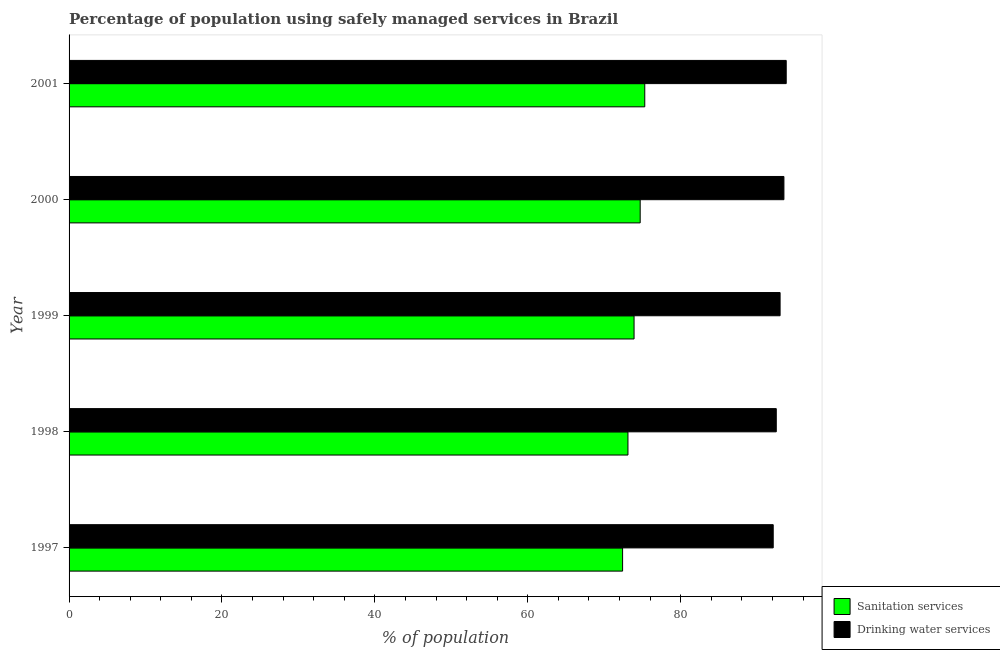How many different coloured bars are there?
Offer a very short reply. 2. How many bars are there on the 5th tick from the top?
Your answer should be compact. 2. In how many cases, is the number of bars for a given year not equal to the number of legend labels?
Give a very brief answer. 0. What is the percentage of population who used drinking water services in 2001?
Keep it short and to the point. 93.8. Across all years, what is the maximum percentage of population who used drinking water services?
Ensure brevity in your answer.  93.8. Across all years, what is the minimum percentage of population who used sanitation services?
Provide a short and direct response. 72.4. In which year was the percentage of population who used sanitation services maximum?
Give a very brief answer. 2001. In which year was the percentage of population who used sanitation services minimum?
Offer a terse response. 1997. What is the total percentage of population who used sanitation services in the graph?
Provide a short and direct response. 369.4. What is the difference between the percentage of population who used sanitation services in 1998 and the percentage of population who used drinking water services in 1997?
Offer a terse response. -19. What is the average percentage of population who used drinking water services per year?
Ensure brevity in your answer.  92.98. In the year 1999, what is the difference between the percentage of population who used sanitation services and percentage of population who used drinking water services?
Your answer should be very brief. -19.1. In how many years, is the percentage of population who used sanitation services greater than 92 %?
Ensure brevity in your answer.  0. Is the percentage of population who used sanitation services in 1997 less than that in 2000?
Keep it short and to the point. Yes. Is the sum of the percentage of population who used drinking water services in 1999 and 2001 greater than the maximum percentage of population who used sanitation services across all years?
Ensure brevity in your answer.  Yes. What does the 2nd bar from the top in 1997 represents?
Your response must be concise. Sanitation services. What does the 2nd bar from the bottom in 1999 represents?
Your answer should be very brief. Drinking water services. How many years are there in the graph?
Offer a very short reply. 5. Does the graph contain any zero values?
Offer a terse response. No. Where does the legend appear in the graph?
Your answer should be compact. Bottom right. How many legend labels are there?
Your answer should be compact. 2. What is the title of the graph?
Ensure brevity in your answer.  Percentage of population using safely managed services in Brazil. Does "Taxes on exports" appear as one of the legend labels in the graph?
Offer a terse response. No. What is the label or title of the X-axis?
Keep it short and to the point. % of population. What is the label or title of the Y-axis?
Offer a terse response. Year. What is the % of population of Sanitation services in 1997?
Your answer should be very brief. 72.4. What is the % of population of Drinking water services in 1997?
Make the answer very short. 92.1. What is the % of population in Sanitation services in 1998?
Your response must be concise. 73.1. What is the % of population of Drinking water services in 1998?
Offer a terse response. 92.5. What is the % of population in Sanitation services in 1999?
Ensure brevity in your answer.  73.9. What is the % of population of Drinking water services in 1999?
Provide a short and direct response. 93. What is the % of population in Sanitation services in 2000?
Offer a terse response. 74.7. What is the % of population of Drinking water services in 2000?
Keep it short and to the point. 93.5. What is the % of population of Sanitation services in 2001?
Your answer should be compact. 75.3. What is the % of population of Drinking water services in 2001?
Your response must be concise. 93.8. Across all years, what is the maximum % of population in Sanitation services?
Your answer should be compact. 75.3. Across all years, what is the maximum % of population in Drinking water services?
Provide a short and direct response. 93.8. Across all years, what is the minimum % of population of Sanitation services?
Make the answer very short. 72.4. Across all years, what is the minimum % of population in Drinking water services?
Offer a very short reply. 92.1. What is the total % of population in Sanitation services in the graph?
Your answer should be compact. 369.4. What is the total % of population of Drinking water services in the graph?
Give a very brief answer. 464.9. What is the difference between the % of population of Sanitation services in 1997 and that in 1998?
Provide a succinct answer. -0.7. What is the difference between the % of population in Drinking water services in 1997 and that in 1998?
Offer a terse response. -0.4. What is the difference between the % of population of Drinking water services in 1997 and that in 1999?
Provide a short and direct response. -0.9. What is the difference between the % of population of Sanitation services in 1997 and that in 2000?
Keep it short and to the point. -2.3. What is the difference between the % of population of Sanitation services in 1997 and that in 2001?
Provide a short and direct response. -2.9. What is the difference between the % of population of Drinking water services in 1997 and that in 2001?
Ensure brevity in your answer.  -1.7. What is the difference between the % of population in Sanitation services in 1998 and that in 1999?
Give a very brief answer. -0.8. What is the difference between the % of population of Sanitation services in 1998 and that in 2000?
Ensure brevity in your answer.  -1.6. What is the difference between the % of population of Drinking water services in 1998 and that in 2000?
Your response must be concise. -1. What is the difference between the % of population in Sanitation services in 1998 and that in 2001?
Give a very brief answer. -2.2. What is the difference between the % of population in Sanitation services in 1999 and that in 2000?
Your answer should be very brief. -0.8. What is the difference between the % of population of Drinking water services in 1999 and that in 2001?
Your response must be concise. -0.8. What is the difference between the % of population of Sanitation services in 2000 and that in 2001?
Ensure brevity in your answer.  -0.6. What is the difference between the % of population of Sanitation services in 1997 and the % of population of Drinking water services in 1998?
Keep it short and to the point. -20.1. What is the difference between the % of population of Sanitation services in 1997 and the % of population of Drinking water services in 1999?
Your response must be concise. -20.6. What is the difference between the % of population in Sanitation services in 1997 and the % of population in Drinking water services in 2000?
Provide a short and direct response. -21.1. What is the difference between the % of population in Sanitation services in 1997 and the % of population in Drinking water services in 2001?
Your response must be concise. -21.4. What is the difference between the % of population of Sanitation services in 1998 and the % of population of Drinking water services in 1999?
Make the answer very short. -19.9. What is the difference between the % of population of Sanitation services in 1998 and the % of population of Drinking water services in 2000?
Offer a terse response. -20.4. What is the difference between the % of population of Sanitation services in 1998 and the % of population of Drinking water services in 2001?
Give a very brief answer. -20.7. What is the difference between the % of population in Sanitation services in 1999 and the % of population in Drinking water services in 2000?
Your answer should be very brief. -19.6. What is the difference between the % of population in Sanitation services in 1999 and the % of population in Drinking water services in 2001?
Provide a short and direct response. -19.9. What is the difference between the % of population in Sanitation services in 2000 and the % of population in Drinking water services in 2001?
Offer a very short reply. -19.1. What is the average % of population of Sanitation services per year?
Offer a very short reply. 73.88. What is the average % of population in Drinking water services per year?
Your response must be concise. 92.98. In the year 1997, what is the difference between the % of population in Sanitation services and % of population in Drinking water services?
Make the answer very short. -19.7. In the year 1998, what is the difference between the % of population in Sanitation services and % of population in Drinking water services?
Offer a very short reply. -19.4. In the year 1999, what is the difference between the % of population in Sanitation services and % of population in Drinking water services?
Your response must be concise. -19.1. In the year 2000, what is the difference between the % of population in Sanitation services and % of population in Drinking water services?
Your answer should be compact. -18.8. In the year 2001, what is the difference between the % of population in Sanitation services and % of population in Drinking water services?
Provide a succinct answer. -18.5. What is the ratio of the % of population in Sanitation services in 1997 to that in 1998?
Offer a very short reply. 0.99. What is the ratio of the % of population in Sanitation services in 1997 to that in 1999?
Offer a very short reply. 0.98. What is the ratio of the % of population of Drinking water services in 1997 to that in 1999?
Your response must be concise. 0.99. What is the ratio of the % of population in Sanitation services in 1997 to that in 2000?
Keep it short and to the point. 0.97. What is the ratio of the % of population in Sanitation services in 1997 to that in 2001?
Your answer should be compact. 0.96. What is the ratio of the % of population of Drinking water services in 1997 to that in 2001?
Ensure brevity in your answer.  0.98. What is the ratio of the % of population in Sanitation services in 1998 to that in 2000?
Your response must be concise. 0.98. What is the ratio of the % of population in Drinking water services in 1998 to that in 2000?
Your answer should be compact. 0.99. What is the ratio of the % of population of Sanitation services in 1998 to that in 2001?
Make the answer very short. 0.97. What is the ratio of the % of population of Drinking water services in 1998 to that in 2001?
Provide a short and direct response. 0.99. What is the ratio of the % of population in Sanitation services in 1999 to that in 2000?
Make the answer very short. 0.99. What is the ratio of the % of population of Sanitation services in 1999 to that in 2001?
Offer a terse response. 0.98. What is the ratio of the % of population in Drinking water services in 1999 to that in 2001?
Provide a succinct answer. 0.99. What is the ratio of the % of population of Drinking water services in 2000 to that in 2001?
Ensure brevity in your answer.  1. What is the difference between the highest and the second highest % of population of Sanitation services?
Offer a terse response. 0.6. 